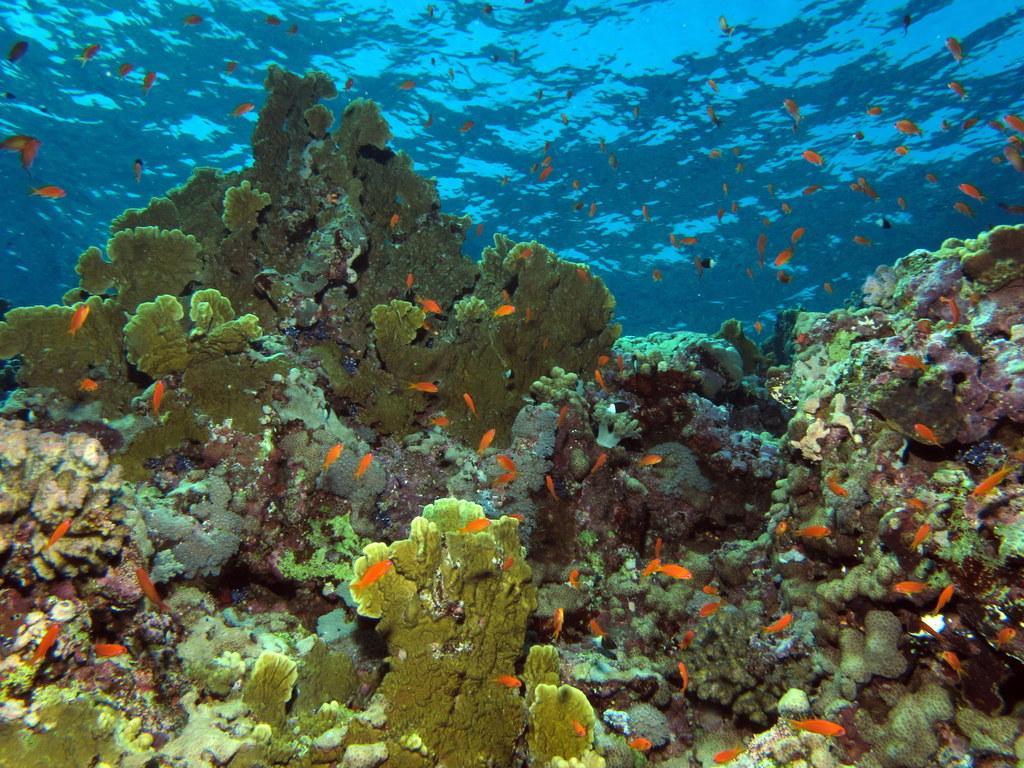Can you describe this image briefly? This picture is consists of underwater view and there are fish around the area of the image. 